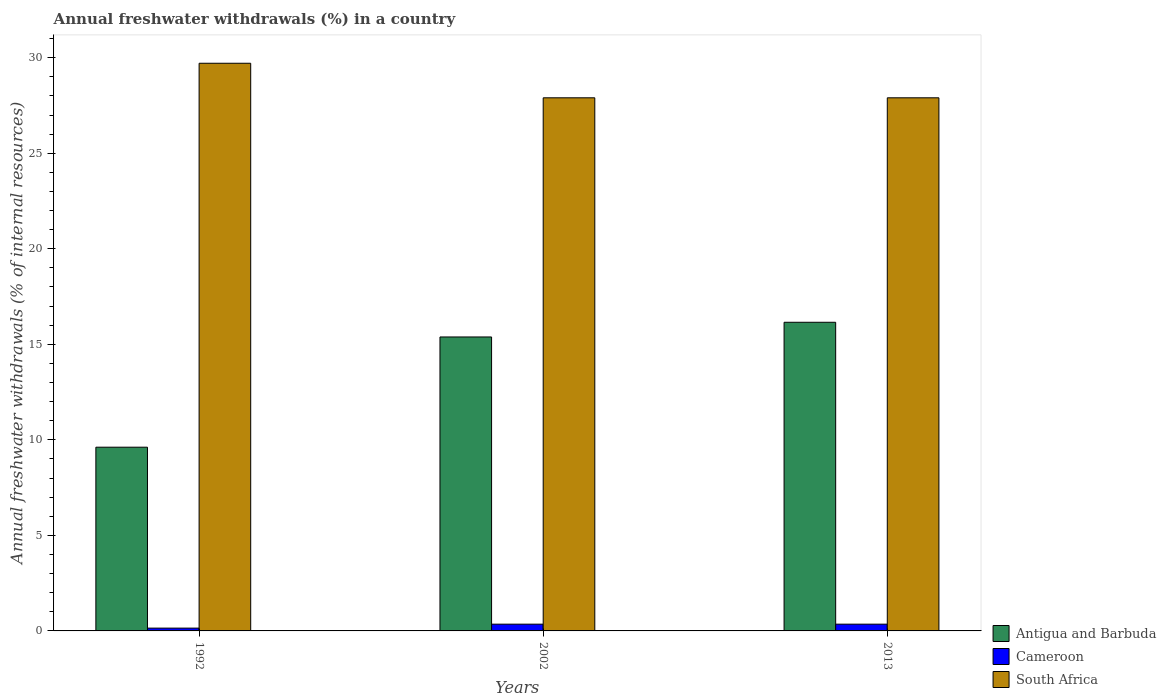Are the number of bars per tick equal to the number of legend labels?
Your answer should be compact. Yes. Are the number of bars on each tick of the X-axis equal?
Keep it short and to the point. Yes. What is the percentage of annual freshwater withdrawals in South Africa in 2002?
Offer a very short reply. 27.9. Across all years, what is the maximum percentage of annual freshwater withdrawals in Antigua and Barbuda?
Make the answer very short. 16.15. Across all years, what is the minimum percentage of annual freshwater withdrawals in South Africa?
Provide a succinct answer. 27.9. In which year was the percentage of annual freshwater withdrawals in Antigua and Barbuda minimum?
Provide a succinct answer. 1992. What is the total percentage of annual freshwater withdrawals in Cameroon in the graph?
Keep it short and to the point. 0.85. What is the difference between the percentage of annual freshwater withdrawals in Cameroon in 1992 and that in 2002?
Your response must be concise. -0.21. What is the difference between the percentage of annual freshwater withdrawals in Antigua and Barbuda in 1992 and the percentage of annual freshwater withdrawals in Cameroon in 2013?
Keep it short and to the point. 9.26. What is the average percentage of annual freshwater withdrawals in South Africa per year?
Offer a very short reply. 28.5. In the year 2013, what is the difference between the percentage of annual freshwater withdrawals in South Africa and percentage of annual freshwater withdrawals in Cameroon?
Offer a very short reply. 27.55. In how many years, is the percentage of annual freshwater withdrawals in Antigua and Barbuda greater than 4 %?
Offer a very short reply. 3. What is the ratio of the percentage of annual freshwater withdrawals in Cameroon in 1992 to that in 2002?
Offer a very short reply. 0.41. Is the percentage of annual freshwater withdrawals in South Africa in 1992 less than that in 2013?
Give a very brief answer. No. What is the difference between the highest and the lowest percentage of annual freshwater withdrawals in Antigua and Barbuda?
Keep it short and to the point. 6.54. What does the 1st bar from the left in 2002 represents?
Offer a very short reply. Antigua and Barbuda. What does the 1st bar from the right in 1992 represents?
Keep it short and to the point. South Africa. How many bars are there?
Ensure brevity in your answer.  9. Are all the bars in the graph horizontal?
Your answer should be very brief. No. How many years are there in the graph?
Keep it short and to the point. 3. What is the difference between two consecutive major ticks on the Y-axis?
Your answer should be very brief. 5. Are the values on the major ticks of Y-axis written in scientific E-notation?
Make the answer very short. No. Does the graph contain any zero values?
Offer a very short reply. No. Where does the legend appear in the graph?
Your answer should be very brief. Bottom right. What is the title of the graph?
Offer a very short reply. Annual freshwater withdrawals (%) in a country. What is the label or title of the Y-axis?
Offer a terse response. Annual freshwater withdrawals (% of internal resources). What is the Annual freshwater withdrawals (% of internal resources) in Antigua and Barbuda in 1992?
Your answer should be compact. 9.62. What is the Annual freshwater withdrawals (% of internal resources) in Cameroon in 1992?
Provide a short and direct response. 0.15. What is the Annual freshwater withdrawals (% of internal resources) of South Africa in 1992?
Make the answer very short. 29.71. What is the Annual freshwater withdrawals (% of internal resources) in Antigua and Barbuda in 2002?
Ensure brevity in your answer.  15.38. What is the Annual freshwater withdrawals (% of internal resources) of Cameroon in 2002?
Your answer should be compact. 0.35. What is the Annual freshwater withdrawals (% of internal resources) of South Africa in 2002?
Keep it short and to the point. 27.9. What is the Annual freshwater withdrawals (% of internal resources) of Antigua and Barbuda in 2013?
Your answer should be compact. 16.15. What is the Annual freshwater withdrawals (% of internal resources) in Cameroon in 2013?
Offer a terse response. 0.35. What is the Annual freshwater withdrawals (% of internal resources) in South Africa in 2013?
Give a very brief answer. 27.9. Across all years, what is the maximum Annual freshwater withdrawals (% of internal resources) in Antigua and Barbuda?
Offer a very short reply. 16.15. Across all years, what is the maximum Annual freshwater withdrawals (% of internal resources) in Cameroon?
Your answer should be very brief. 0.35. Across all years, what is the maximum Annual freshwater withdrawals (% of internal resources) in South Africa?
Offer a terse response. 29.71. Across all years, what is the minimum Annual freshwater withdrawals (% of internal resources) in Antigua and Barbuda?
Your response must be concise. 9.62. Across all years, what is the minimum Annual freshwater withdrawals (% of internal resources) of Cameroon?
Provide a short and direct response. 0.15. Across all years, what is the minimum Annual freshwater withdrawals (% of internal resources) of South Africa?
Your answer should be compact. 27.9. What is the total Annual freshwater withdrawals (% of internal resources) in Antigua and Barbuda in the graph?
Provide a short and direct response. 41.15. What is the total Annual freshwater withdrawals (% of internal resources) of Cameroon in the graph?
Offer a very short reply. 0.85. What is the total Annual freshwater withdrawals (% of internal resources) in South Africa in the graph?
Provide a succinct answer. 85.51. What is the difference between the Annual freshwater withdrawals (% of internal resources) of Antigua and Barbuda in 1992 and that in 2002?
Keep it short and to the point. -5.77. What is the difference between the Annual freshwater withdrawals (% of internal resources) of Cameroon in 1992 and that in 2002?
Your response must be concise. -0.21. What is the difference between the Annual freshwater withdrawals (% of internal resources) in South Africa in 1992 and that in 2002?
Provide a short and direct response. 1.81. What is the difference between the Annual freshwater withdrawals (% of internal resources) in Antigua and Barbuda in 1992 and that in 2013?
Your response must be concise. -6.54. What is the difference between the Annual freshwater withdrawals (% of internal resources) of Cameroon in 1992 and that in 2013?
Your response must be concise. -0.21. What is the difference between the Annual freshwater withdrawals (% of internal resources) of South Africa in 1992 and that in 2013?
Give a very brief answer. 1.81. What is the difference between the Annual freshwater withdrawals (% of internal resources) in Antigua and Barbuda in 2002 and that in 2013?
Offer a very short reply. -0.77. What is the difference between the Annual freshwater withdrawals (% of internal resources) in Cameroon in 2002 and that in 2013?
Your answer should be very brief. 0. What is the difference between the Annual freshwater withdrawals (% of internal resources) in South Africa in 2002 and that in 2013?
Your answer should be compact. 0. What is the difference between the Annual freshwater withdrawals (% of internal resources) in Antigua and Barbuda in 1992 and the Annual freshwater withdrawals (% of internal resources) in Cameroon in 2002?
Your answer should be compact. 9.26. What is the difference between the Annual freshwater withdrawals (% of internal resources) in Antigua and Barbuda in 1992 and the Annual freshwater withdrawals (% of internal resources) in South Africa in 2002?
Provide a succinct answer. -18.29. What is the difference between the Annual freshwater withdrawals (% of internal resources) in Cameroon in 1992 and the Annual freshwater withdrawals (% of internal resources) in South Africa in 2002?
Give a very brief answer. -27.76. What is the difference between the Annual freshwater withdrawals (% of internal resources) of Antigua and Barbuda in 1992 and the Annual freshwater withdrawals (% of internal resources) of Cameroon in 2013?
Keep it short and to the point. 9.26. What is the difference between the Annual freshwater withdrawals (% of internal resources) in Antigua and Barbuda in 1992 and the Annual freshwater withdrawals (% of internal resources) in South Africa in 2013?
Ensure brevity in your answer.  -18.29. What is the difference between the Annual freshwater withdrawals (% of internal resources) in Cameroon in 1992 and the Annual freshwater withdrawals (% of internal resources) in South Africa in 2013?
Keep it short and to the point. -27.76. What is the difference between the Annual freshwater withdrawals (% of internal resources) in Antigua and Barbuda in 2002 and the Annual freshwater withdrawals (% of internal resources) in Cameroon in 2013?
Your answer should be compact. 15.03. What is the difference between the Annual freshwater withdrawals (% of internal resources) of Antigua and Barbuda in 2002 and the Annual freshwater withdrawals (% of internal resources) of South Africa in 2013?
Ensure brevity in your answer.  -12.52. What is the difference between the Annual freshwater withdrawals (% of internal resources) of Cameroon in 2002 and the Annual freshwater withdrawals (% of internal resources) of South Africa in 2013?
Provide a short and direct response. -27.55. What is the average Annual freshwater withdrawals (% of internal resources) in Antigua and Barbuda per year?
Your response must be concise. 13.72. What is the average Annual freshwater withdrawals (% of internal resources) in Cameroon per year?
Make the answer very short. 0.28. What is the average Annual freshwater withdrawals (% of internal resources) in South Africa per year?
Provide a succinct answer. 28.5. In the year 1992, what is the difference between the Annual freshwater withdrawals (% of internal resources) of Antigua and Barbuda and Annual freshwater withdrawals (% of internal resources) of Cameroon?
Provide a short and direct response. 9.47. In the year 1992, what is the difference between the Annual freshwater withdrawals (% of internal resources) of Antigua and Barbuda and Annual freshwater withdrawals (% of internal resources) of South Africa?
Give a very brief answer. -20.09. In the year 1992, what is the difference between the Annual freshwater withdrawals (% of internal resources) of Cameroon and Annual freshwater withdrawals (% of internal resources) of South Africa?
Ensure brevity in your answer.  -29.56. In the year 2002, what is the difference between the Annual freshwater withdrawals (% of internal resources) in Antigua and Barbuda and Annual freshwater withdrawals (% of internal resources) in Cameroon?
Give a very brief answer. 15.03. In the year 2002, what is the difference between the Annual freshwater withdrawals (% of internal resources) of Antigua and Barbuda and Annual freshwater withdrawals (% of internal resources) of South Africa?
Make the answer very short. -12.52. In the year 2002, what is the difference between the Annual freshwater withdrawals (% of internal resources) of Cameroon and Annual freshwater withdrawals (% of internal resources) of South Africa?
Your answer should be very brief. -27.55. In the year 2013, what is the difference between the Annual freshwater withdrawals (% of internal resources) of Antigua and Barbuda and Annual freshwater withdrawals (% of internal resources) of Cameroon?
Ensure brevity in your answer.  15.8. In the year 2013, what is the difference between the Annual freshwater withdrawals (% of internal resources) of Antigua and Barbuda and Annual freshwater withdrawals (% of internal resources) of South Africa?
Offer a terse response. -11.75. In the year 2013, what is the difference between the Annual freshwater withdrawals (% of internal resources) in Cameroon and Annual freshwater withdrawals (% of internal resources) in South Africa?
Give a very brief answer. -27.55. What is the ratio of the Annual freshwater withdrawals (% of internal resources) in Cameroon in 1992 to that in 2002?
Make the answer very short. 0.41. What is the ratio of the Annual freshwater withdrawals (% of internal resources) of South Africa in 1992 to that in 2002?
Provide a succinct answer. 1.06. What is the ratio of the Annual freshwater withdrawals (% of internal resources) in Antigua and Barbuda in 1992 to that in 2013?
Your response must be concise. 0.6. What is the ratio of the Annual freshwater withdrawals (% of internal resources) of Cameroon in 1992 to that in 2013?
Make the answer very short. 0.41. What is the ratio of the Annual freshwater withdrawals (% of internal resources) in South Africa in 1992 to that in 2013?
Offer a very short reply. 1.06. What is the difference between the highest and the second highest Annual freshwater withdrawals (% of internal resources) in Antigua and Barbuda?
Your answer should be compact. 0.77. What is the difference between the highest and the second highest Annual freshwater withdrawals (% of internal resources) of Cameroon?
Offer a terse response. 0. What is the difference between the highest and the second highest Annual freshwater withdrawals (% of internal resources) in South Africa?
Your answer should be compact. 1.81. What is the difference between the highest and the lowest Annual freshwater withdrawals (% of internal resources) in Antigua and Barbuda?
Provide a succinct answer. 6.54. What is the difference between the highest and the lowest Annual freshwater withdrawals (% of internal resources) of Cameroon?
Your answer should be compact. 0.21. What is the difference between the highest and the lowest Annual freshwater withdrawals (% of internal resources) in South Africa?
Make the answer very short. 1.81. 